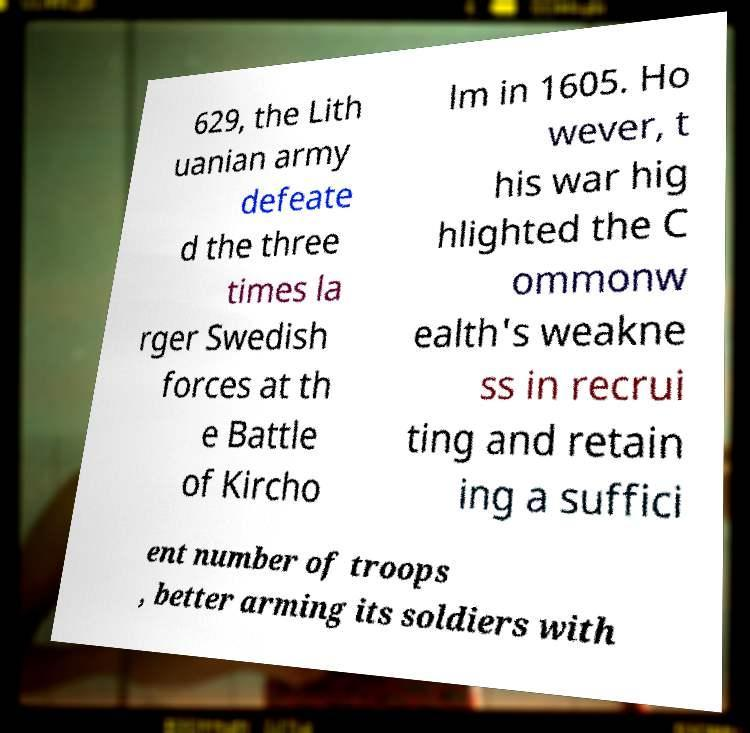What messages or text are displayed in this image? I need them in a readable, typed format. 629, the Lith uanian army defeate d the three times la rger Swedish forces at th e Battle of Kircho lm in 1605. Ho wever, t his war hig hlighted the C ommonw ealth's weakne ss in recrui ting and retain ing a suffici ent number of troops , better arming its soldiers with 